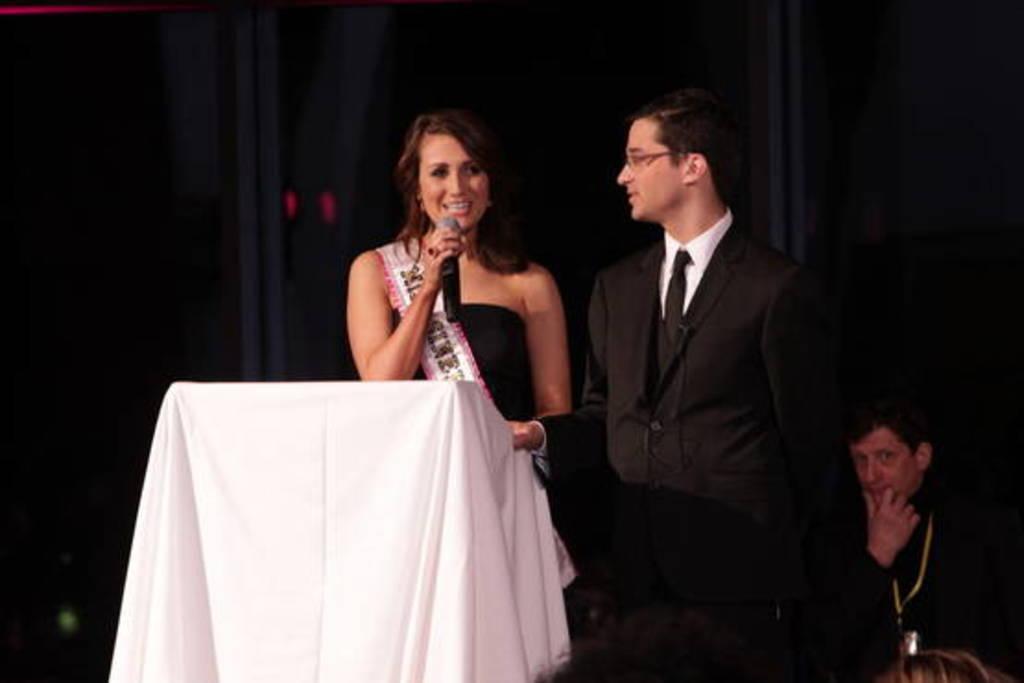Can you describe this image briefly? In this image we can see a man and a woman. Man is wearing black color suit and woman is wearing black color dress and holding mic in her hand. In front of her white color table is there. Right bottom of the image, one more person is sitting. 